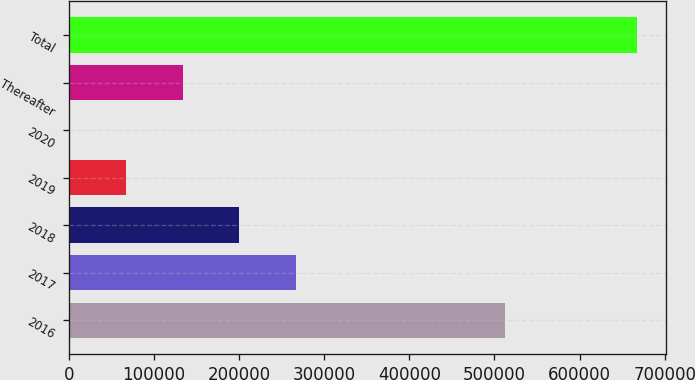Convert chart. <chart><loc_0><loc_0><loc_500><loc_500><bar_chart><fcel>2016<fcel>2017<fcel>2018<fcel>2019<fcel>2020<fcel>Thereafter<fcel>Total<nl><fcel>512836<fcel>267208<fcel>200486<fcel>67042.7<fcel>321<fcel>133764<fcel>667538<nl></chart> 